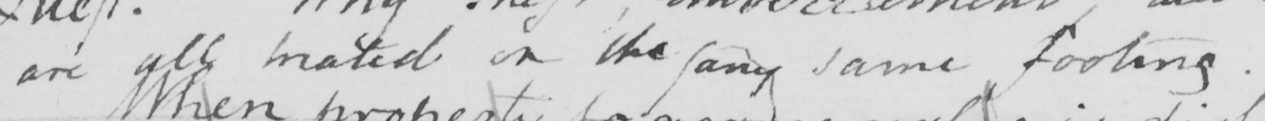Transcribe the text shown in this historical manuscript line. are all  <gap/>  on the any same footing . 